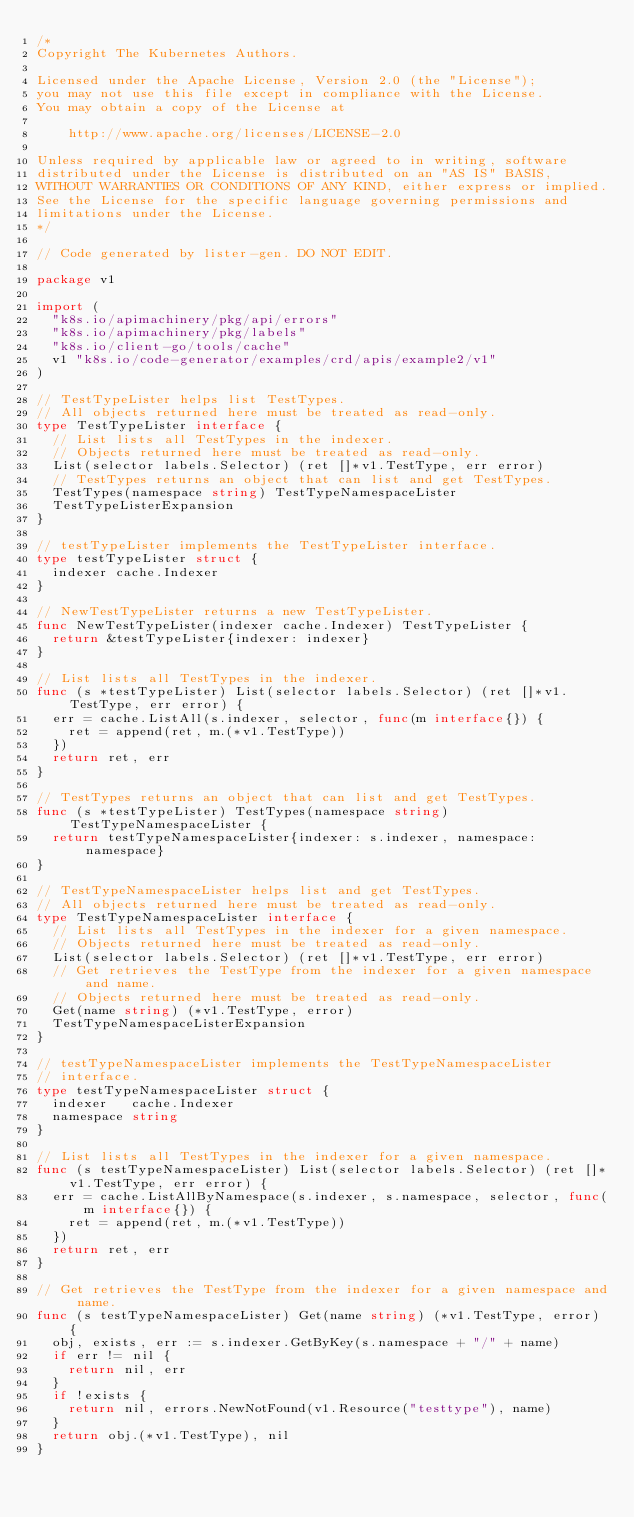<code> <loc_0><loc_0><loc_500><loc_500><_Go_>/*
Copyright The Kubernetes Authors.

Licensed under the Apache License, Version 2.0 (the "License");
you may not use this file except in compliance with the License.
You may obtain a copy of the License at

    http://www.apache.org/licenses/LICENSE-2.0

Unless required by applicable law or agreed to in writing, software
distributed under the License is distributed on an "AS IS" BASIS,
WITHOUT WARRANTIES OR CONDITIONS OF ANY KIND, either express or implied.
See the License for the specific language governing permissions and
limitations under the License.
*/

// Code generated by lister-gen. DO NOT EDIT.

package v1

import (
	"k8s.io/apimachinery/pkg/api/errors"
	"k8s.io/apimachinery/pkg/labels"
	"k8s.io/client-go/tools/cache"
	v1 "k8s.io/code-generator/examples/crd/apis/example2/v1"
)

// TestTypeLister helps list TestTypes.
// All objects returned here must be treated as read-only.
type TestTypeLister interface {
	// List lists all TestTypes in the indexer.
	// Objects returned here must be treated as read-only.
	List(selector labels.Selector) (ret []*v1.TestType, err error)
	// TestTypes returns an object that can list and get TestTypes.
	TestTypes(namespace string) TestTypeNamespaceLister
	TestTypeListerExpansion
}

// testTypeLister implements the TestTypeLister interface.
type testTypeLister struct {
	indexer cache.Indexer
}

// NewTestTypeLister returns a new TestTypeLister.
func NewTestTypeLister(indexer cache.Indexer) TestTypeLister {
	return &testTypeLister{indexer: indexer}
}

// List lists all TestTypes in the indexer.
func (s *testTypeLister) List(selector labels.Selector) (ret []*v1.TestType, err error) {
	err = cache.ListAll(s.indexer, selector, func(m interface{}) {
		ret = append(ret, m.(*v1.TestType))
	})
	return ret, err
}

// TestTypes returns an object that can list and get TestTypes.
func (s *testTypeLister) TestTypes(namespace string) TestTypeNamespaceLister {
	return testTypeNamespaceLister{indexer: s.indexer, namespace: namespace}
}

// TestTypeNamespaceLister helps list and get TestTypes.
// All objects returned here must be treated as read-only.
type TestTypeNamespaceLister interface {
	// List lists all TestTypes in the indexer for a given namespace.
	// Objects returned here must be treated as read-only.
	List(selector labels.Selector) (ret []*v1.TestType, err error)
	// Get retrieves the TestType from the indexer for a given namespace and name.
	// Objects returned here must be treated as read-only.
	Get(name string) (*v1.TestType, error)
	TestTypeNamespaceListerExpansion
}

// testTypeNamespaceLister implements the TestTypeNamespaceLister
// interface.
type testTypeNamespaceLister struct {
	indexer   cache.Indexer
	namespace string
}

// List lists all TestTypes in the indexer for a given namespace.
func (s testTypeNamespaceLister) List(selector labels.Selector) (ret []*v1.TestType, err error) {
	err = cache.ListAllByNamespace(s.indexer, s.namespace, selector, func(m interface{}) {
		ret = append(ret, m.(*v1.TestType))
	})
	return ret, err
}

// Get retrieves the TestType from the indexer for a given namespace and name.
func (s testTypeNamespaceLister) Get(name string) (*v1.TestType, error) {
	obj, exists, err := s.indexer.GetByKey(s.namespace + "/" + name)
	if err != nil {
		return nil, err
	}
	if !exists {
		return nil, errors.NewNotFound(v1.Resource("testtype"), name)
	}
	return obj.(*v1.TestType), nil
}
</code> 